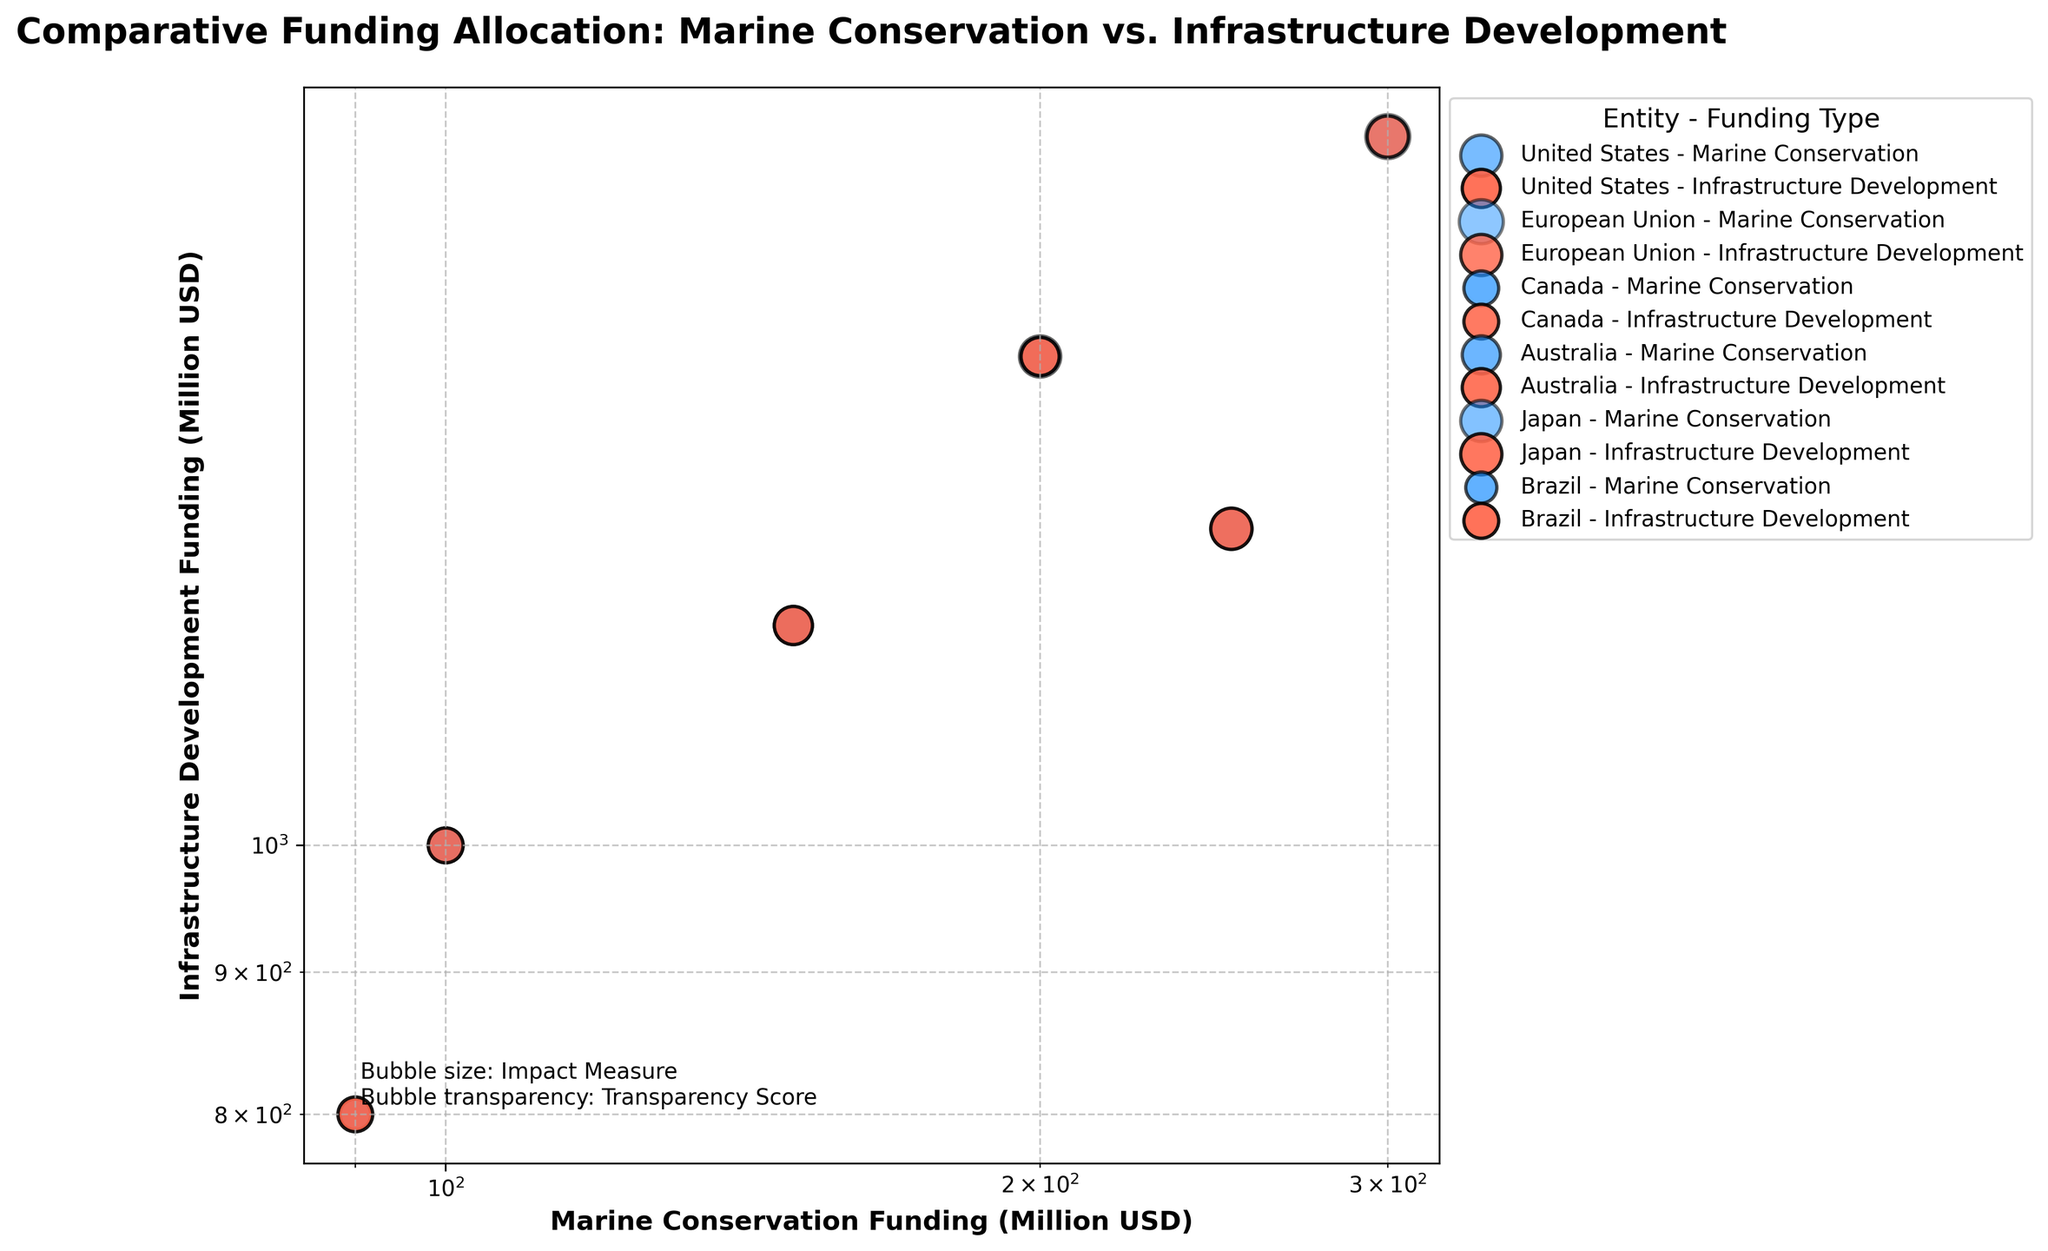How many entities are represented in the figure? Count the unique entities mentioned in the legend of the plot. Each entity has two funding types indicated by different colors.
Answer: Six What are the axis labels on the figure? Check the text next to the horizontal and vertical lines on the plot.
Answer: Marine Conservation Funding (Million USD) for the x-axis and Infrastructure Development Funding (Million USD) for the y-axis Which entity has the highest funding for marine conservation? Locate the points on the horizontal axis representing marine conservation funding and find the one with the highest value.
Answer: European Union Which funding type has higher transparency (opacity) values, marine conservation or infrastructure development? Compare the transparency (opacity) values for each funding type across the entities.
Answer: Infrastructure development What is the range of the impact measure used for the bubble sizes in the plot? Identify the smallest and largest bubble sizes according to the impact measure mentioned in the figure's text description or legend.
Answer: 4 to 8 How does the transparency of bubbles aid in visual interpretation? Consider the role of transparency in visualizing overlapping data points and the ease of distinguishing between bubbles.
Answer: It helps distinguish overlapping bubbles and clarifies overlapping points For Canada, compare the impact measure for marine conservation and infrastructure development. Look for the bubble sizes related to Canada for both funding types; compare the sizes quantitatively.
Answer: Both have an impact measure of 5 Which entity shows equal impact measures for both funding types? Check the bubble sizes for equality across entities for each funding type.
Answer: Canada Is there any entity where the difference in funding between marine conservation and infrastructure development is the smallest? Calculate the difference for each entity and compare. For the closest difference, find the smallest value.
Answer: Brazil (800-90 = 710 million USD) Based on the transparency values, which funding type appears more transparent on average? Average the transparency values for each funding type across all entities and compare.
Answer: Infrastructure development 